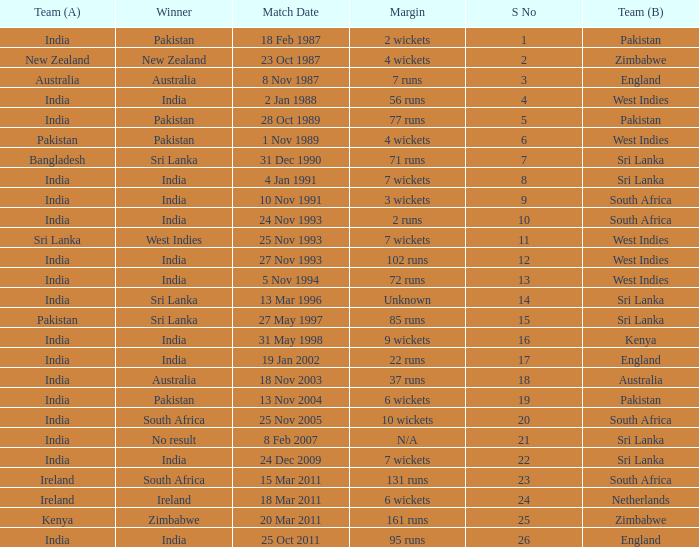Who won the match when the margin was 131 runs? South Africa. 